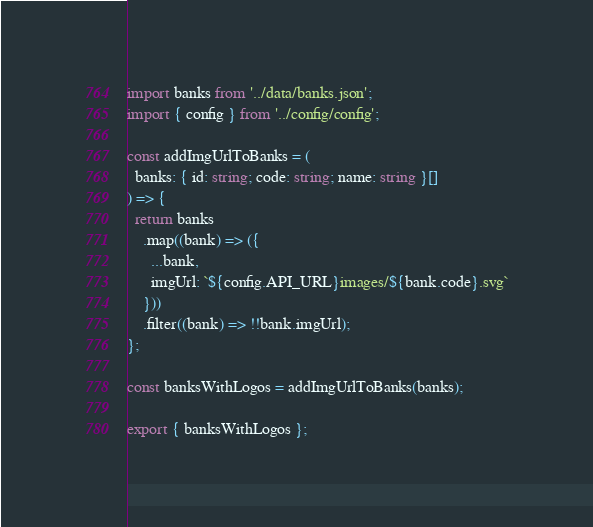<code> <loc_0><loc_0><loc_500><loc_500><_TypeScript_>import banks from '../data/banks.json';
import { config } from '../config/config';

const addImgUrlToBanks = (
  banks: { id: string; code: string; name: string }[]
) => {
  return banks
    .map((bank) => ({
      ...bank,
      imgUrl: `${config.API_URL}images/${bank.code}.svg`
    }))
    .filter((bank) => !!bank.imgUrl);
};

const banksWithLogos = addImgUrlToBanks(banks);

export { banksWithLogos };
</code> 